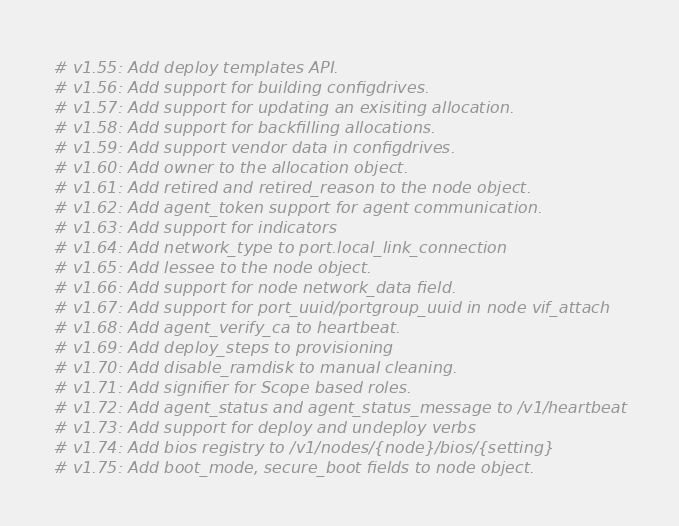Convert code to text. <code><loc_0><loc_0><loc_500><loc_500><_Python_># v1.55: Add deploy templates API.
# v1.56: Add support for building configdrives.
# v1.57: Add support for updating an exisiting allocation.
# v1.58: Add support for backfilling allocations.
# v1.59: Add support vendor data in configdrives.
# v1.60: Add owner to the allocation object.
# v1.61: Add retired and retired_reason to the node object.
# v1.62: Add agent_token support for agent communication.
# v1.63: Add support for indicators
# v1.64: Add network_type to port.local_link_connection
# v1.65: Add lessee to the node object.
# v1.66: Add support for node network_data field.
# v1.67: Add support for port_uuid/portgroup_uuid in node vif_attach
# v1.68: Add agent_verify_ca to heartbeat.
# v1.69: Add deploy_steps to provisioning
# v1.70: Add disable_ramdisk to manual cleaning.
# v1.71: Add signifier for Scope based roles.
# v1.72: Add agent_status and agent_status_message to /v1/heartbeat
# v1.73: Add support for deploy and undeploy verbs
# v1.74: Add bios registry to /v1/nodes/{node}/bios/{setting}
# v1.75: Add boot_mode, secure_boot fields to node object.
</code> 